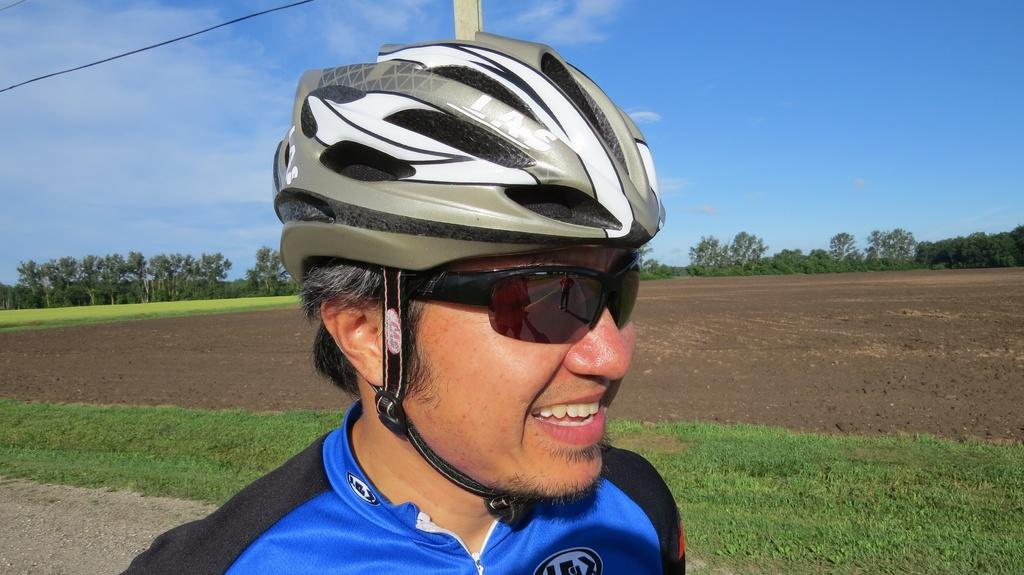What is the person in the image wearing on their head? The person in the image is wearing a helmet. Where is the person located in the image? The person is on a field. What type of natural environment is visible in the image? There are many trees in the image. What type of stretch is the person performing in the image? There is no stretch being performed in the image; the person is simply wearing a helmet and standing on a field. 